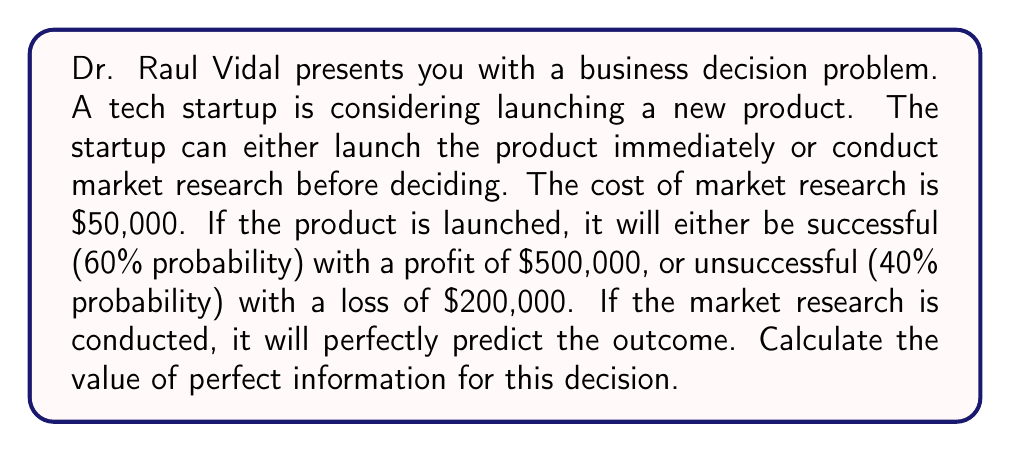Teach me how to tackle this problem. To solve this problem, we'll follow these steps:

1) First, let's calculate the expected value (EV) of launching without information:

   $$EV_{without} = 0.6 \times 500,000 + 0.4 \times (-200,000) = 300,000 - 80,000 = $220,000$$

2) Now, let's calculate the expected value with perfect information:

   If the research predicts success (60% chance):
   $$EV_{success} = 500,000 - 50,000 = $450,000$$

   If the research predicts failure (40% chance):
   $$EV_{failure} = 0 - 50,000 = -$50,000$$ (we don't launch, only pay for research)

   $$EV_{with} = 0.6 \times 450,000 + 0.4 \times (-50,000) = 270,000 - 20,000 = $250,000$$

3) The value of perfect information (VPI) is the difference between these expected values:

   $$VPI = EV_{with} - EV_{without} = 250,000 - 220,000 = $30,000$$

This means that the perfect information provided by the market research is worth $30,000 to the decision-maker.

Here's a decision tree to visualize the problem:

[asy]
import geometry;

pair A=(0,0), B=(100,50), C=(100,-50), D=(200,100), E=(200,0), F=(200,-100);

draw(A--B--D);
draw(A--C--E);
draw(B--E);
draw(C--F);

label("Start", A, W);
label("Research", B, W);
label("No Research", C, W);
label("Success (60%)", D, E);
label("Failure (40%)", E, E);
label("Success (60%)", E, W);
label("Failure (40%)", F, E);

label("$450,000", (B+D)/2, N);
label("-$50,000", (B+E)/2, S);
label("$500,000", (C+E)/2, N);
label("-$200,000", (C+F)/2, S);
[/asy]
Answer: The value of perfect information is $30,000. 